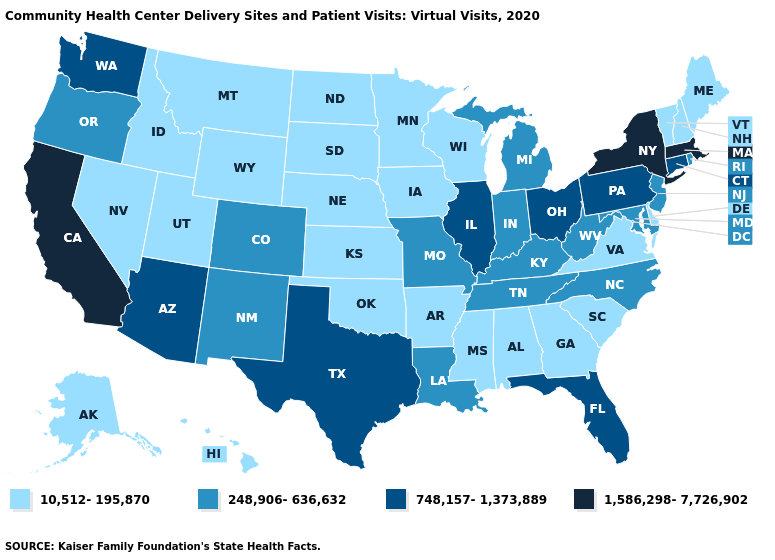What is the highest value in the USA?
Short answer required. 1,586,298-7,726,902. What is the value of South Carolina?
Write a very short answer. 10,512-195,870. Does New Hampshire have the lowest value in the Northeast?
Give a very brief answer. Yes. Which states hav the highest value in the Northeast?
Quick response, please. Massachusetts, New York. Among the states that border Oregon , which have the lowest value?
Short answer required. Idaho, Nevada. Does Alabama have the lowest value in the South?
Short answer required. Yes. Does California have the highest value in the West?
Quick response, please. Yes. Which states have the lowest value in the West?
Concise answer only. Alaska, Hawaii, Idaho, Montana, Nevada, Utah, Wyoming. Does Illinois have the highest value in the MidWest?
Quick response, please. Yes. Is the legend a continuous bar?
Concise answer only. No. What is the lowest value in states that border New Jersey?
Give a very brief answer. 10,512-195,870. Name the states that have a value in the range 248,906-636,632?
Answer briefly. Colorado, Indiana, Kentucky, Louisiana, Maryland, Michigan, Missouri, New Jersey, New Mexico, North Carolina, Oregon, Rhode Island, Tennessee, West Virginia. Name the states that have a value in the range 10,512-195,870?
Concise answer only. Alabama, Alaska, Arkansas, Delaware, Georgia, Hawaii, Idaho, Iowa, Kansas, Maine, Minnesota, Mississippi, Montana, Nebraska, Nevada, New Hampshire, North Dakota, Oklahoma, South Carolina, South Dakota, Utah, Vermont, Virginia, Wisconsin, Wyoming. Name the states that have a value in the range 10,512-195,870?
Concise answer only. Alabama, Alaska, Arkansas, Delaware, Georgia, Hawaii, Idaho, Iowa, Kansas, Maine, Minnesota, Mississippi, Montana, Nebraska, Nevada, New Hampshire, North Dakota, Oklahoma, South Carolina, South Dakota, Utah, Vermont, Virginia, Wisconsin, Wyoming. Is the legend a continuous bar?
Write a very short answer. No. 